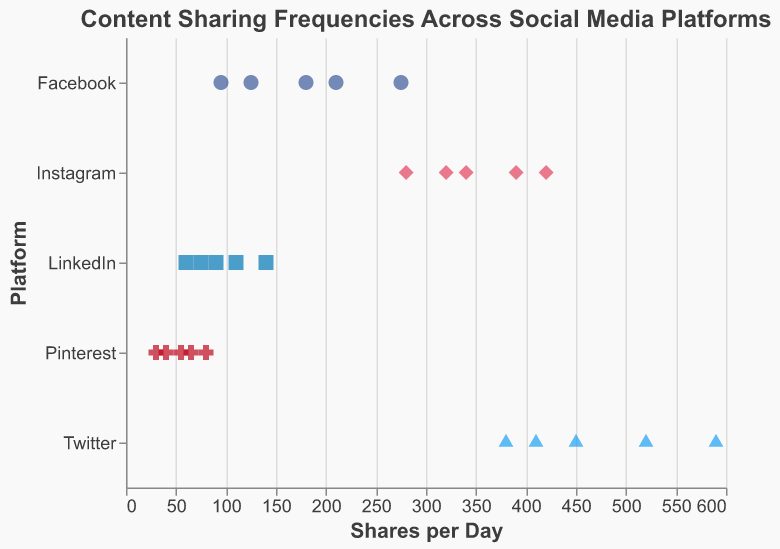What is the title of the chart? The title of the chart is displayed at the top of the figure and reads "Content Sharing Frequencies Across Social Media Platforms" in bold.
Answer: Content Sharing Frequencies Across Social Media Platforms Which platform has the highest number of shares per day? By looking at the data points, the highest number of shares per day is indicated by the point farthest to the right, under the label "Twitter".
Answer: Twitter What color represents Instagram in the chart? Each social media platform is represented by a different color. Instagram is denoted by the color pink.
Answer: Pink How many data points are shown for Pinterest? By counting the number of points along the Y-axis where "Pinterest" is labeled, there are 5 data points for Pinterest.
Answer: 5 What is the range of shares per day for Facebook? The range of shares per day for Facebook is determined by the minimum and maximum values of the points related to Facebook. The minimum is 95 and the maximum is 275, hence the range is 275 - 95 = 180.
Answer: 180 Which platform has the most variability in the data points? To determine which platform has the most variability, observe the spread of points on the X-axis for each platform. Twitter has the widest spread of points, indicating the most variability.
Answer: Twitter What is the median shares per day for Instagram? The median is found by arranging the shares per day for Instagram (280, 320, 340, 390, 420) and finding the middle value. The median is 340.
Answer: 340 Which platform has shares per day consistently below 100? By examining the positions of the data points, LinkedIn has all its points below 100.
Answer: LinkedIn Compare the highest number of shares per day between Twitter and Instagram. Which is greater and by how much? The highest number of shares per day for Twitter is 590, while for Instagram it is 420. The difference is 590 - 420 = 170.
Answer: Twitter by 170 What is the average number of shares per day for Facebook? The sum of shares per day for Facebook is 125 + 210 + 180 + 95 + 275 = 885. There are 5 data points, so the average is 885 / 5 = 177.
Answer: 177 